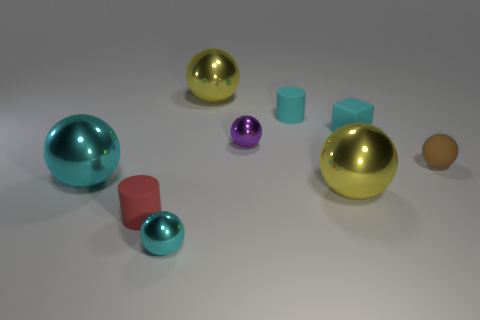Subtract all purple balls. How many balls are left? 5 Subtract all tiny brown rubber balls. How many balls are left? 5 Subtract all green balls. Subtract all brown cylinders. How many balls are left? 6 Subtract all cubes. How many objects are left? 8 Add 4 large green blocks. How many large green blocks exist? 4 Subtract 0 blue blocks. How many objects are left? 9 Subtract all small metallic cubes. Subtract all brown rubber objects. How many objects are left? 8 Add 2 big yellow balls. How many big yellow balls are left? 4 